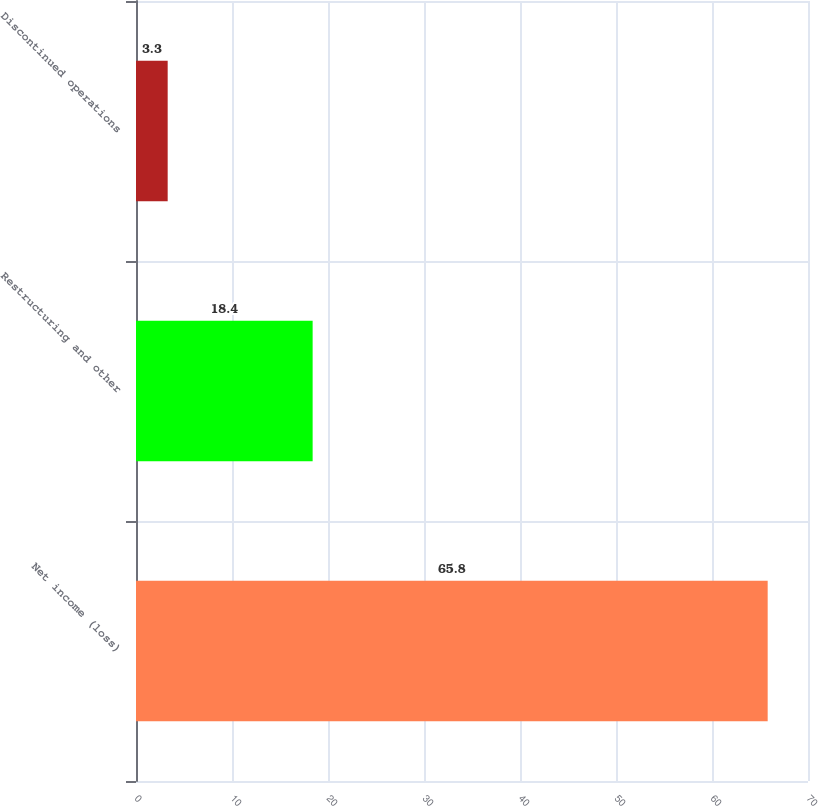Convert chart. <chart><loc_0><loc_0><loc_500><loc_500><bar_chart><fcel>Net income (loss)<fcel>Restructuring and other<fcel>Discontinued operations<nl><fcel>65.8<fcel>18.4<fcel>3.3<nl></chart> 